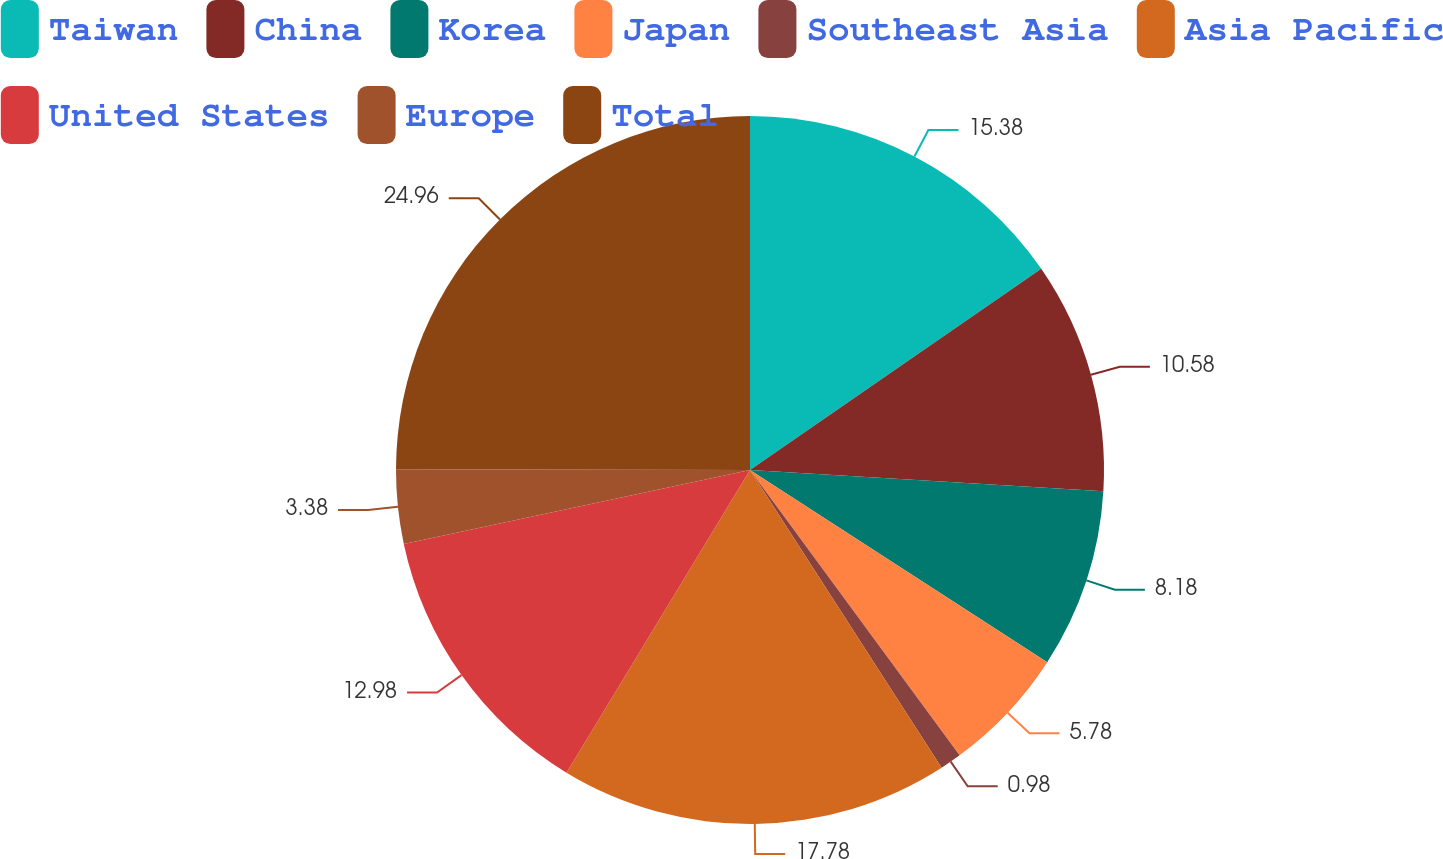Convert chart. <chart><loc_0><loc_0><loc_500><loc_500><pie_chart><fcel>Taiwan<fcel>China<fcel>Korea<fcel>Japan<fcel>Southeast Asia<fcel>Asia Pacific<fcel>United States<fcel>Europe<fcel>Total<nl><fcel>15.38%<fcel>10.58%<fcel>8.18%<fcel>5.78%<fcel>0.98%<fcel>17.78%<fcel>12.98%<fcel>3.38%<fcel>24.97%<nl></chart> 